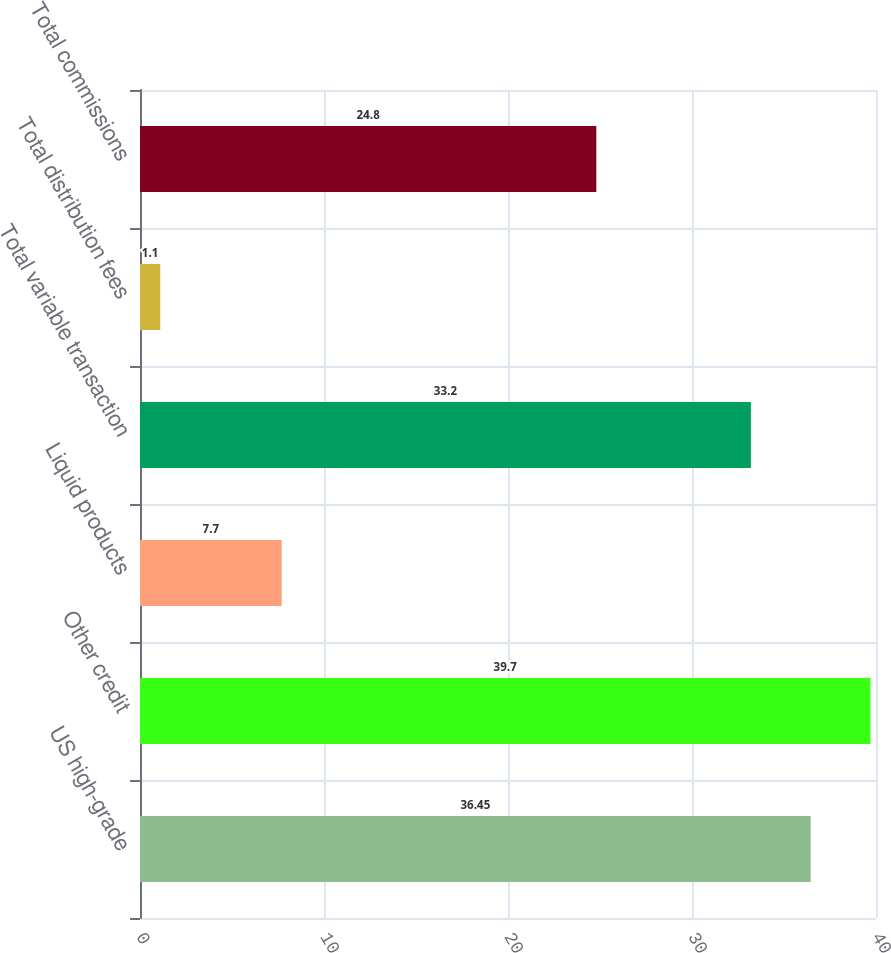<chart> <loc_0><loc_0><loc_500><loc_500><bar_chart><fcel>US high-grade<fcel>Other credit<fcel>Liquid products<fcel>Total variable transaction<fcel>Total distribution fees<fcel>Total commissions<nl><fcel>36.45<fcel>39.7<fcel>7.7<fcel>33.2<fcel>1.1<fcel>24.8<nl></chart> 